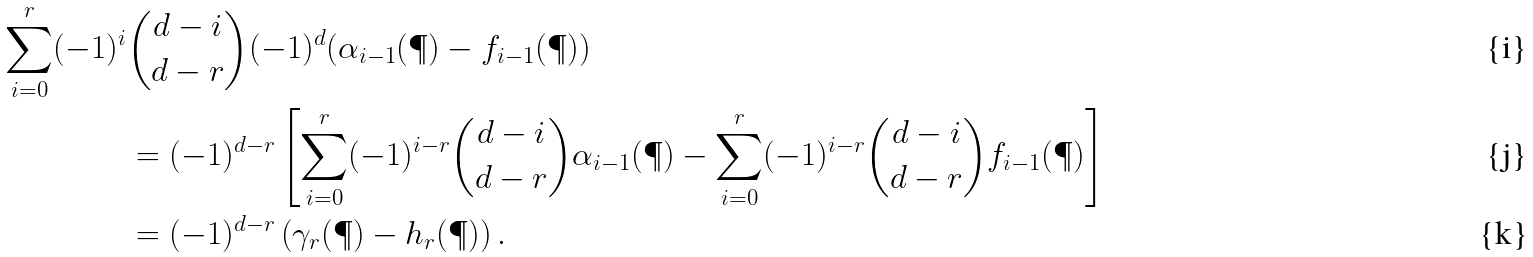Convert formula to latex. <formula><loc_0><loc_0><loc_500><loc_500>\sum _ { i = 0 } ^ { r } ( - 1 ) ^ { i } & { d - i \choose d - r } ( - 1 ) ^ { d } ( \alpha _ { i - 1 } ( \P ) - f _ { i - 1 } ( \P ) ) \\ & = ( - 1 ) ^ { d - r } \left [ \sum _ { i = 0 } ^ { r } ( - 1 ) ^ { i - r } { d - i \choose d - r } \alpha _ { i - 1 } ( \P ) - \sum _ { i = 0 } ^ { r } ( - 1 ) ^ { i - r } { d - i \choose d - r } f _ { i - 1 } ( \P ) \right ] \\ & = ( - 1 ) ^ { d - r } \left ( \gamma _ { r } ( \P ) - h _ { r } ( \P ) \right ) .</formula> 